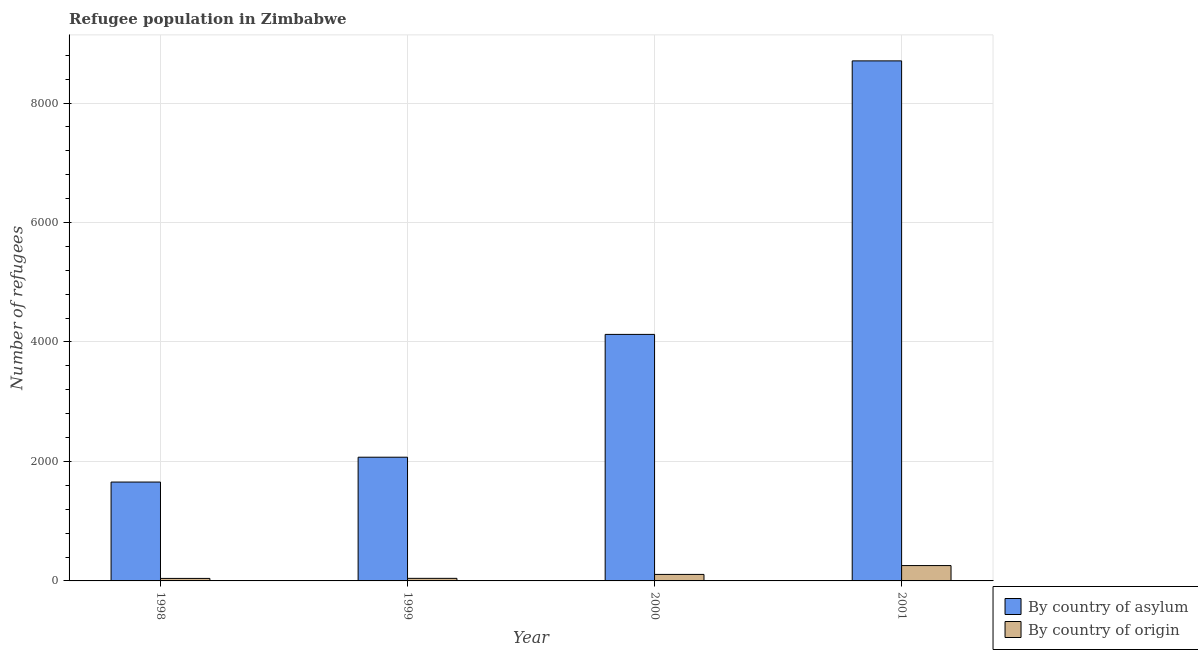How many bars are there on the 2nd tick from the left?
Ensure brevity in your answer.  2. How many bars are there on the 2nd tick from the right?
Keep it short and to the point. 2. What is the label of the 3rd group of bars from the left?
Your answer should be compact. 2000. In how many cases, is the number of bars for a given year not equal to the number of legend labels?
Provide a short and direct response. 0. What is the number of refugees by country of asylum in 2000?
Provide a short and direct response. 4127. Across all years, what is the maximum number of refugees by country of origin?
Your response must be concise. 257. Across all years, what is the minimum number of refugees by country of asylum?
Offer a very short reply. 1655. In which year was the number of refugees by country of asylum maximum?
Provide a short and direct response. 2001. What is the total number of refugees by country of asylum in the graph?
Make the answer very short. 1.66e+04. What is the difference between the number of refugees by country of asylum in 1998 and that in 1999?
Give a very brief answer. -416. What is the difference between the number of refugees by country of asylum in 1998 and the number of refugees by country of origin in 2000?
Give a very brief answer. -2472. What is the average number of refugees by country of asylum per year?
Your answer should be compact. 4139.75. What is the ratio of the number of refugees by country of origin in 2000 to that in 2001?
Offer a very short reply. 0.42. What is the difference between the highest and the second highest number of refugees by country of asylum?
Ensure brevity in your answer.  4579. What is the difference between the highest and the lowest number of refugees by country of asylum?
Offer a very short reply. 7051. Is the sum of the number of refugees by country of asylum in 1999 and 2001 greater than the maximum number of refugees by country of origin across all years?
Your answer should be compact. Yes. What does the 1st bar from the left in 1998 represents?
Your answer should be compact. By country of asylum. What does the 2nd bar from the right in 2001 represents?
Give a very brief answer. By country of asylum. How many bars are there?
Your answer should be compact. 8. Are all the bars in the graph horizontal?
Provide a succinct answer. No. What is the difference between two consecutive major ticks on the Y-axis?
Keep it short and to the point. 2000. Does the graph contain any zero values?
Your response must be concise. No. Does the graph contain grids?
Offer a terse response. Yes. How are the legend labels stacked?
Your answer should be compact. Vertical. What is the title of the graph?
Your answer should be very brief. Refugee population in Zimbabwe. What is the label or title of the Y-axis?
Make the answer very short. Number of refugees. What is the Number of refugees in By country of asylum in 1998?
Your answer should be very brief. 1655. What is the Number of refugees in By country of origin in 1998?
Give a very brief answer. 42. What is the Number of refugees of By country of asylum in 1999?
Your answer should be compact. 2071. What is the Number of refugees in By country of asylum in 2000?
Make the answer very short. 4127. What is the Number of refugees in By country of origin in 2000?
Your response must be concise. 109. What is the Number of refugees of By country of asylum in 2001?
Offer a very short reply. 8706. What is the Number of refugees of By country of origin in 2001?
Give a very brief answer. 257. Across all years, what is the maximum Number of refugees of By country of asylum?
Provide a succinct answer. 8706. Across all years, what is the maximum Number of refugees of By country of origin?
Your answer should be compact. 257. Across all years, what is the minimum Number of refugees in By country of asylum?
Keep it short and to the point. 1655. What is the total Number of refugees in By country of asylum in the graph?
Provide a short and direct response. 1.66e+04. What is the total Number of refugees of By country of origin in the graph?
Your answer should be compact. 451. What is the difference between the Number of refugees of By country of asylum in 1998 and that in 1999?
Offer a very short reply. -416. What is the difference between the Number of refugees in By country of origin in 1998 and that in 1999?
Give a very brief answer. -1. What is the difference between the Number of refugees of By country of asylum in 1998 and that in 2000?
Offer a very short reply. -2472. What is the difference between the Number of refugees of By country of origin in 1998 and that in 2000?
Keep it short and to the point. -67. What is the difference between the Number of refugees of By country of asylum in 1998 and that in 2001?
Your response must be concise. -7051. What is the difference between the Number of refugees in By country of origin in 1998 and that in 2001?
Keep it short and to the point. -215. What is the difference between the Number of refugees in By country of asylum in 1999 and that in 2000?
Provide a succinct answer. -2056. What is the difference between the Number of refugees of By country of origin in 1999 and that in 2000?
Provide a succinct answer. -66. What is the difference between the Number of refugees in By country of asylum in 1999 and that in 2001?
Ensure brevity in your answer.  -6635. What is the difference between the Number of refugees of By country of origin in 1999 and that in 2001?
Ensure brevity in your answer.  -214. What is the difference between the Number of refugees of By country of asylum in 2000 and that in 2001?
Your answer should be very brief. -4579. What is the difference between the Number of refugees in By country of origin in 2000 and that in 2001?
Your response must be concise. -148. What is the difference between the Number of refugees of By country of asylum in 1998 and the Number of refugees of By country of origin in 1999?
Provide a succinct answer. 1612. What is the difference between the Number of refugees in By country of asylum in 1998 and the Number of refugees in By country of origin in 2000?
Keep it short and to the point. 1546. What is the difference between the Number of refugees of By country of asylum in 1998 and the Number of refugees of By country of origin in 2001?
Your response must be concise. 1398. What is the difference between the Number of refugees in By country of asylum in 1999 and the Number of refugees in By country of origin in 2000?
Your answer should be very brief. 1962. What is the difference between the Number of refugees of By country of asylum in 1999 and the Number of refugees of By country of origin in 2001?
Keep it short and to the point. 1814. What is the difference between the Number of refugees in By country of asylum in 2000 and the Number of refugees in By country of origin in 2001?
Provide a short and direct response. 3870. What is the average Number of refugees in By country of asylum per year?
Your answer should be very brief. 4139.75. What is the average Number of refugees in By country of origin per year?
Offer a terse response. 112.75. In the year 1998, what is the difference between the Number of refugees in By country of asylum and Number of refugees in By country of origin?
Make the answer very short. 1613. In the year 1999, what is the difference between the Number of refugees in By country of asylum and Number of refugees in By country of origin?
Your answer should be very brief. 2028. In the year 2000, what is the difference between the Number of refugees of By country of asylum and Number of refugees of By country of origin?
Your answer should be compact. 4018. In the year 2001, what is the difference between the Number of refugees in By country of asylum and Number of refugees in By country of origin?
Ensure brevity in your answer.  8449. What is the ratio of the Number of refugees in By country of asylum in 1998 to that in 1999?
Provide a succinct answer. 0.8. What is the ratio of the Number of refugees of By country of origin in 1998 to that in 1999?
Give a very brief answer. 0.98. What is the ratio of the Number of refugees of By country of asylum in 1998 to that in 2000?
Ensure brevity in your answer.  0.4. What is the ratio of the Number of refugees of By country of origin in 1998 to that in 2000?
Give a very brief answer. 0.39. What is the ratio of the Number of refugees in By country of asylum in 1998 to that in 2001?
Give a very brief answer. 0.19. What is the ratio of the Number of refugees in By country of origin in 1998 to that in 2001?
Keep it short and to the point. 0.16. What is the ratio of the Number of refugees of By country of asylum in 1999 to that in 2000?
Keep it short and to the point. 0.5. What is the ratio of the Number of refugees in By country of origin in 1999 to that in 2000?
Your answer should be very brief. 0.39. What is the ratio of the Number of refugees of By country of asylum in 1999 to that in 2001?
Your answer should be very brief. 0.24. What is the ratio of the Number of refugees in By country of origin in 1999 to that in 2001?
Your answer should be compact. 0.17. What is the ratio of the Number of refugees of By country of asylum in 2000 to that in 2001?
Make the answer very short. 0.47. What is the ratio of the Number of refugees of By country of origin in 2000 to that in 2001?
Provide a succinct answer. 0.42. What is the difference between the highest and the second highest Number of refugees of By country of asylum?
Your response must be concise. 4579. What is the difference between the highest and the second highest Number of refugees of By country of origin?
Offer a very short reply. 148. What is the difference between the highest and the lowest Number of refugees in By country of asylum?
Keep it short and to the point. 7051. What is the difference between the highest and the lowest Number of refugees of By country of origin?
Keep it short and to the point. 215. 